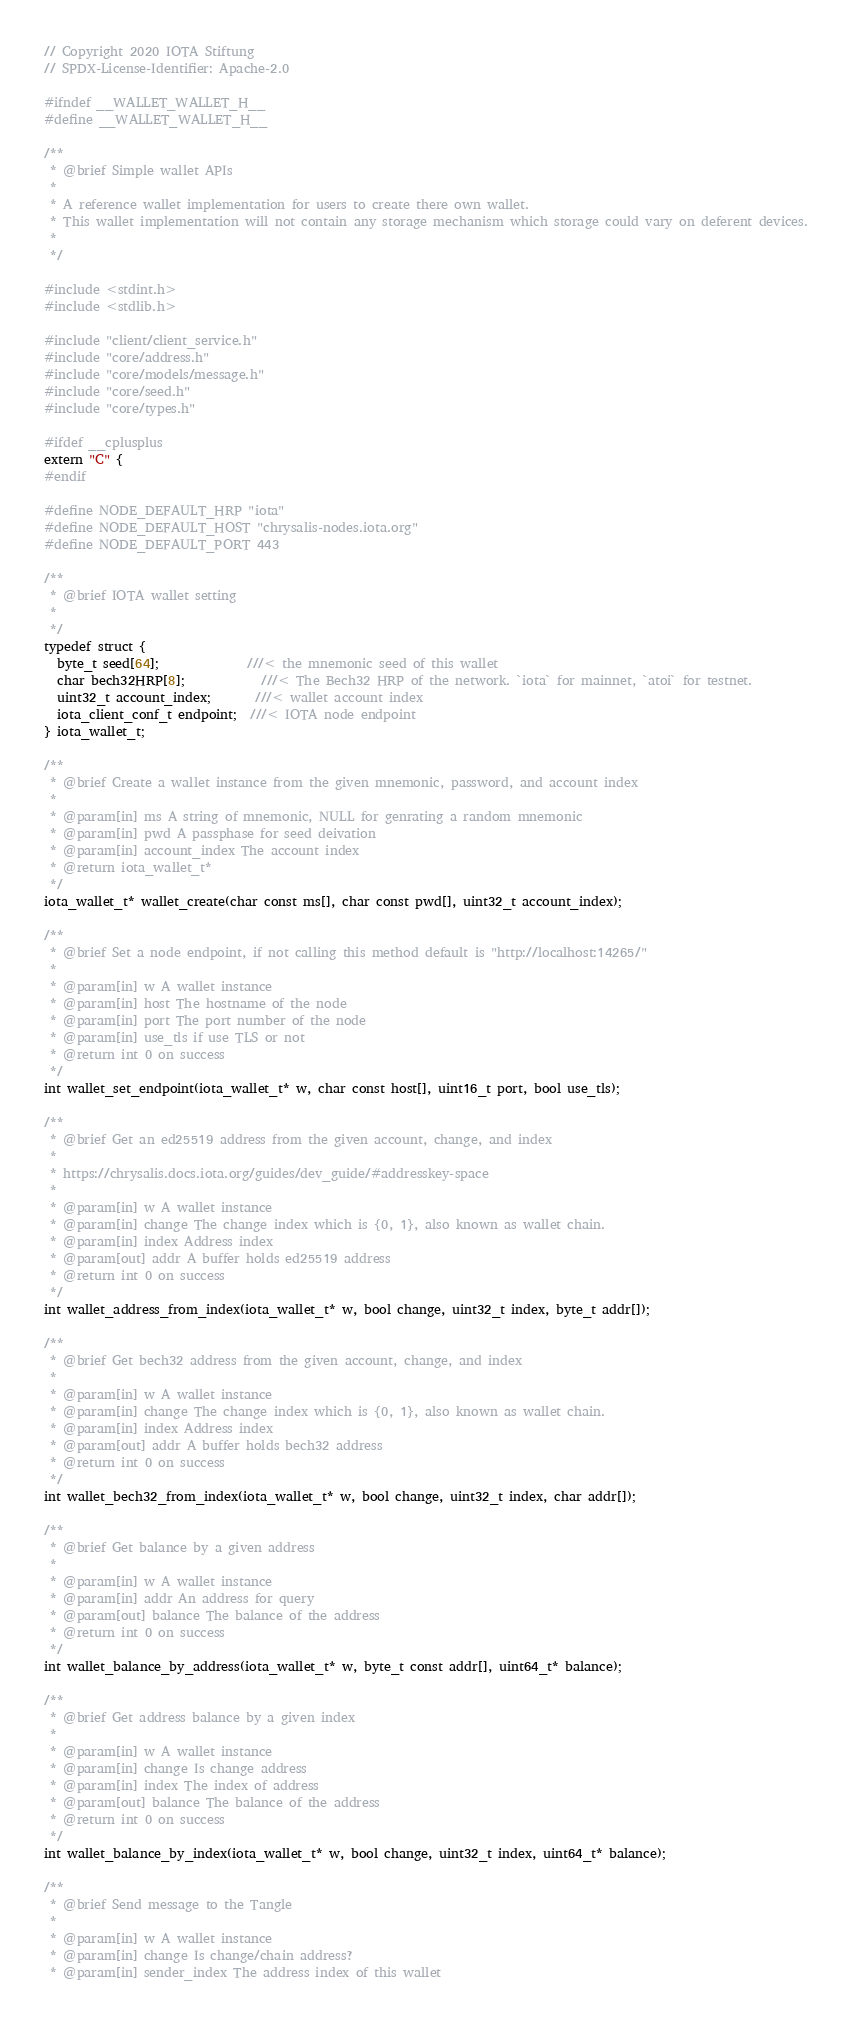Convert code to text. <code><loc_0><loc_0><loc_500><loc_500><_C_>// Copyright 2020 IOTA Stiftung
// SPDX-License-Identifier: Apache-2.0

#ifndef __WALLET_WALLET_H__
#define __WALLET_WALLET_H__

/**
 * @brief Simple wallet APIs
 *
 * A reference wallet implementation for users to create there own wallet.
 * This wallet implementation will not contain any storage mechanism which storage could vary on deferent devices.
 *
 */

#include <stdint.h>
#include <stdlib.h>

#include "client/client_service.h"
#include "core/address.h"
#include "core/models/message.h"
#include "core/seed.h"
#include "core/types.h"

#ifdef __cplusplus
extern "C" {
#endif

#define NODE_DEFAULT_HRP "iota"
#define NODE_DEFAULT_HOST "chrysalis-nodes.iota.org"
#define NODE_DEFAULT_PORT 443

/**
 * @brief IOTA wallet setting
 *
 */
typedef struct {
  byte_t seed[64];              ///< the mnemonic seed of this wallet
  char bech32HRP[8];            ///< The Bech32 HRP of the network. `iota` for mainnet, `atoi` for testnet.
  uint32_t account_index;       ///< wallet account index
  iota_client_conf_t endpoint;  ///< IOTA node endpoint
} iota_wallet_t;

/**
 * @brief Create a wallet instance from the given mnemonic, password, and account index
 *
 * @param[in] ms A string of mnemonic, NULL for genrating a random mnemonic
 * @param[in] pwd A passphase for seed deivation
 * @param[in] account_index The account index
 * @return iota_wallet_t*
 */
iota_wallet_t* wallet_create(char const ms[], char const pwd[], uint32_t account_index);

/**
 * @brief Set a node endpoint, if not calling this method default is "http://localhost:14265/"
 *
 * @param[in] w A wallet instance
 * @param[in] host The hostname of the node
 * @param[in] port The port number of the node
 * @param[in] use_tls if use TLS or not
 * @return int 0 on success
 */
int wallet_set_endpoint(iota_wallet_t* w, char const host[], uint16_t port, bool use_tls);

/**
 * @brief Get an ed25519 address from the given account, change, and index
 *
 * https://chrysalis.docs.iota.org/guides/dev_guide/#addresskey-space
 *
 * @param[in] w A wallet instance
 * @param[in] change The change index which is {0, 1}, also known as wallet chain.
 * @param[in] index Address index
 * @param[out] addr A buffer holds ed25519 address
 * @return int 0 on success
 */
int wallet_address_from_index(iota_wallet_t* w, bool change, uint32_t index, byte_t addr[]);

/**
 * @brief Get bech32 address from the given account, change, and index
 *
 * @param[in] w A wallet instance
 * @param[in] change The change index which is {0, 1}, also known as wallet chain.
 * @param[in] index Address index
 * @param[out] addr A buffer holds bech32 address
 * @return int 0 on success
 */
int wallet_bech32_from_index(iota_wallet_t* w, bool change, uint32_t index, char addr[]);

/**
 * @brief Get balance by a given address
 *
 * @param[in] w A wallet instance
 * @param[in] addr An address for query
 * @param[out] balance The balance of the address
 * @return int 0 on success
 */
int wallet_balance_by_address(iota_wallet_t* w, byte_t const addr[], uint64_t* balance);

/**
 * @brief Get address balance by a given index
 *
 * @param[in] w A wallet instance
 * @param[in] change Is change address
 * @param[in] index The index of address
 * @param[out] balance The balance of the address
 * @return int 0 on success
 */
int wallet_balance_by_index(iota_wallet_t* w, bool change, uint32_t index, uint64_t* balance);

/**
 * @brief Send message to the Tangle
 *
 * @param[in] w A wallet instance
 * @param[in] change Is change/chain address?
 * @param[in] sender_index The address index of this wallet</code> 